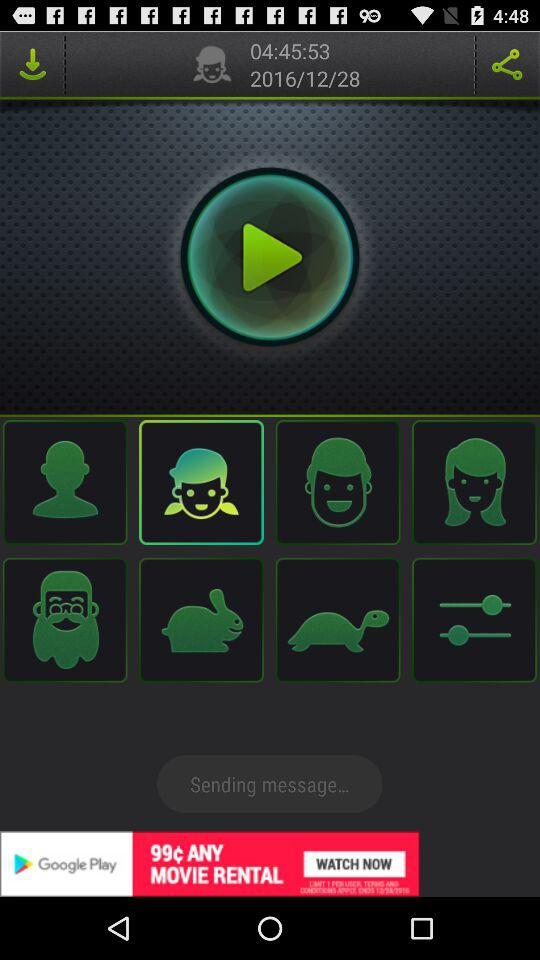What is the time duration of the media? The time duration is 4 hours 45 minutes 53 seconds. 